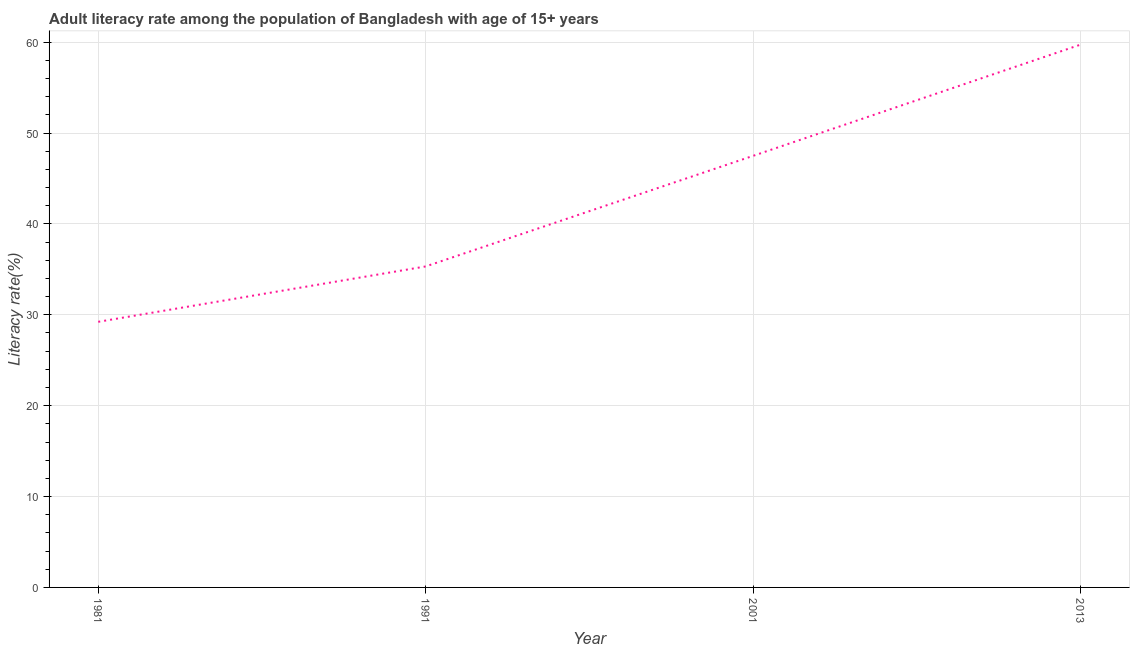What is the adult literacy rate in 1991?
Your response must be concise. 35.32. Across all years, what is the maximum adult literacy rate?
Provide a short and direct response. 59.72. Across all years, what is the minimum adult literacy rate?
Make the answer very short. 29.23. In which year was the adult literacy rate maximum?
Your response must be concise. 2013. In which year was the adult literacy rate minimum?
Give a very brief answer. 1981. What is the sum of the adult literacy rate?
Your answer should be compact. 171.75. What is the difference between the adult literacy rate in 1991 and 2001?
Your answer should be very brief. -12.17. What is the average adult literacy rate per year?
Make the answer very short. 42.94. What is the median adult literacy rate?
Your answer should be very brief. 41.4. What is the ratio of the adult literacy rate in 1981 to that in 2013?
Offer a very short reply. 0.49. Is the difference between the adult literacy rate in 1981 and 2013 greater than the difference between any two years?
Make the answer very short. Yes. What is the difference between the highest and the second highest adult literacy rate?
Provide a succinct answer. 12.24. Is the sum of the adult literacy rate in 1981 and 2013 greater than the maximum adult literacy rate across all years?
Your answer should be compact. Yes. What is the difference between the highest and the lowest adult literacy rate?
Your answer should be very brief. 30.49. In how many years, is the adult literacy rate greater than the average adult literacy rate taken over all years?
Your response must be concise. 2. Does the adult literacy rate monotonically increase over the years?
Make the answer very short. Yes. How many lines are there?
Keep it short and to the point. 1. Does the graph contain grids?
Your answer should be compact. Yes. What is the title of the graph?
Offer a terse response. Adult literacy rate among the population of Bangladesh with age of 15+ years. What is the label or title of the Y-axis?
Offer a very short reply. Literacy rate(%). What is the Literacy rate(%) in 1981?
Offer a very short reply. 29.23. What is the Literacy rate(%) in 1991?
Provide a short and direct response. 35.32. What is the Literacy rate(%) in 2001?
Provide a succinct answer. 47.49. What is the Literacy rate(%) of 2013?
Offer a very short reply. 59.72. What is the difference between the Literacy rate(%) in 1981 and 1991?
Offer a very short reply. -6.09. What is the difference between the Literacy rate(%) in 1981 and 2001?
Ensure brevity in your answer.  -18.26. What is the difference between the Literacy rate(%) in 1981 and 2013?
Make the answer very short. -30.49. What is the difference between the Literacy rate(%) in 1991 and 2001?
Your answer should be compact. -12.17. What is the difference between the Literacy rate(%) in 1991 and 2013?
Offer a very short reply. -24.4. What is the difference between the Literacy rate(%) in 2001 and 2013?
Your answer should be compact. -12.24. What is the ratio of the Literacy rate(%) in 1981 to that in 1991?
Offer a terse response. 0.83. What is the ratio of the Literacy rate(%) in 1981 to that in 2001?
Make the answer very short. 0.61. What is the ratio of the Literacy rate(%) in 1981 to that in 2013?
Your response must be concise. 0.49. What is the ratio of the Literacy rate(%) in 1991 to that in 2001?
Provide a succinct answer. 0.74. What is the ratio of the Literacy rate(%) in 1991 to that in 2013?
Your response must be concise. 0.59. What is the ratio of the Literacy rate(%) in 2001 to that in 2013?
Your answer should be compact. 0.8. 